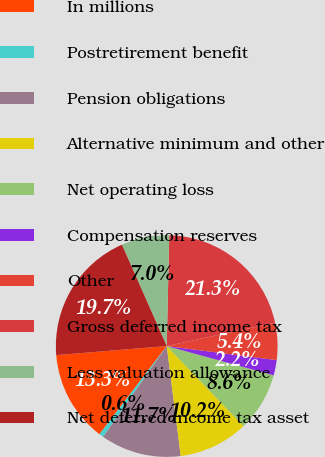<chart> <loc_0><loc_0><loc_500><loc_500><pie_chart><fcel>In millions<fcel>Postretirement benefit<fcel>Pension obligations<fcel>Alternative minimum and other<fcel>Net operating loss<fcel>Compensation reserves<fcel>Other<fcel>Gross deferred income tax<fcel>Less valuation allowance<fcel>Net deferred income tax asset<nl><fcel>13.33%<fcel>0.64%<fcel>11.74%<fcel>10.16%<fcel>8.57%<fcel>2.23%<fcel>5.4%<fcel>21.26%<fcel>6.99%<fcel>19.68%<nl></chart> 